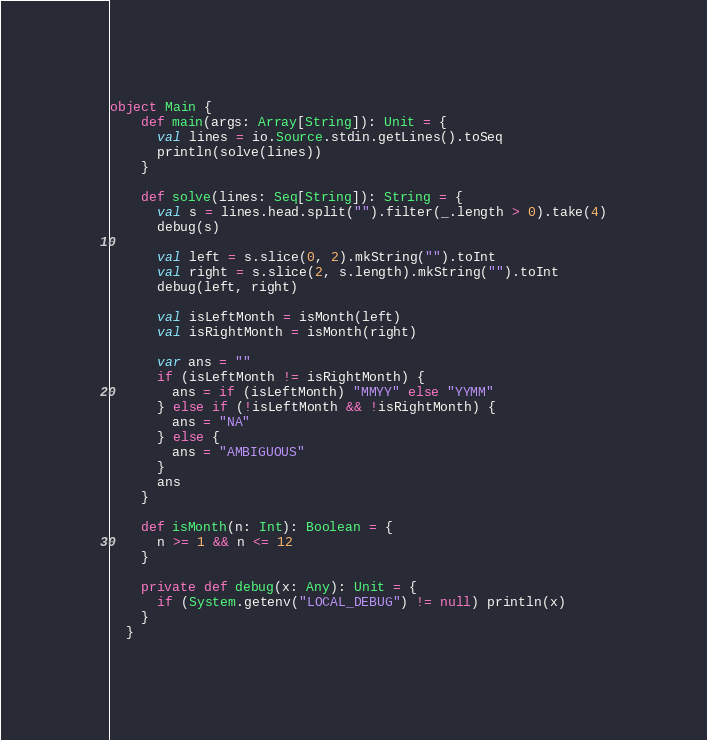<code> <loc_0><loc_0><loc_500><loc_500><_Scala_>object Main {
    def main(args: Array[String]): Unit = {
      val lines = io.Source.stdin.getLines().toSeq
      println(solve(lines))
    }

    def solve(lines: Seq[String]): String = {
      val s = lines.head.split("").filter(_.length > 0).take(4)
      debug(s)

      val left = s.slice(0, 2).mkString("").toInt
      val right = s.slice(2, s.length).mkString("").toInt
      debug(left, right)

      val isLeftMonth = isMonth(left)
      val isRightMonth = isMonth(right)

      var ans = ""
      if (isLeftMonth != isRightMonth) {
        ans = if (isLeftMonth) "MMYY" else "YYMM"
      } else if (!isLeftMonth && !isRightMonth) {
        ans = "NA"
      } else {
        ans = "AMBIGUOUS"
      }
      ans
    }

    def isMonth(n: Int): Boolean = {
      n >= 1 && n <= 12
    }

    private def debug(x: Any): Unit = {
      if (System.getenv("LOCAL_DEBUG") != null) println(x)
    }
  }</code> 